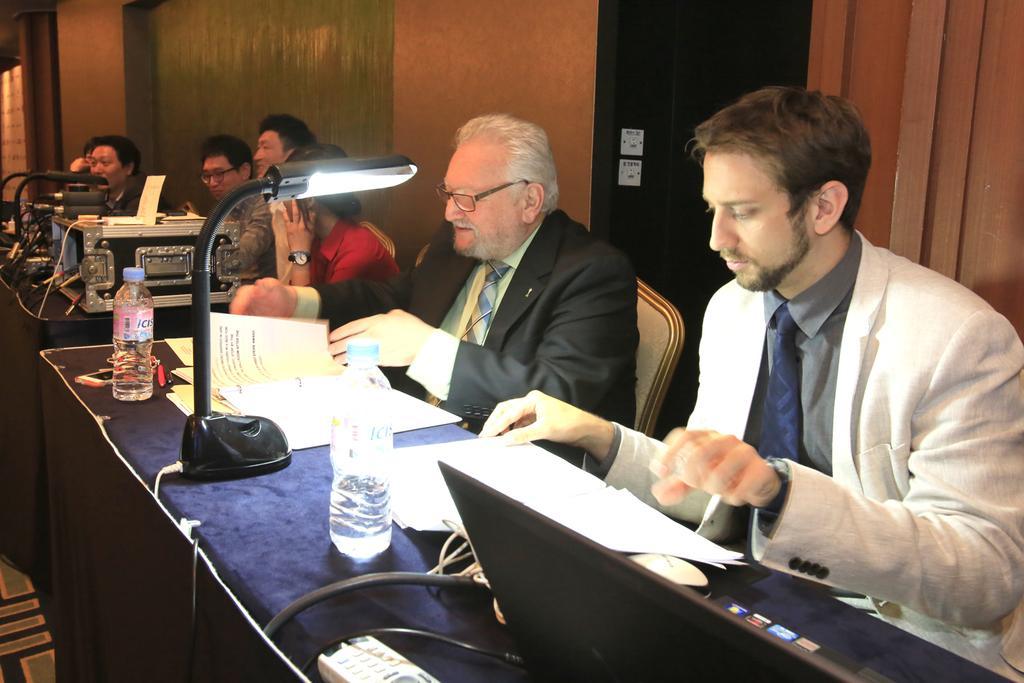How would you summarize this image in a sentence or two? In this image we can see some people sitting on chairs behind the table containing laptop, papers, containers, bottles, lights and some devices on it. In the background, we can see switch boards on the wall. 